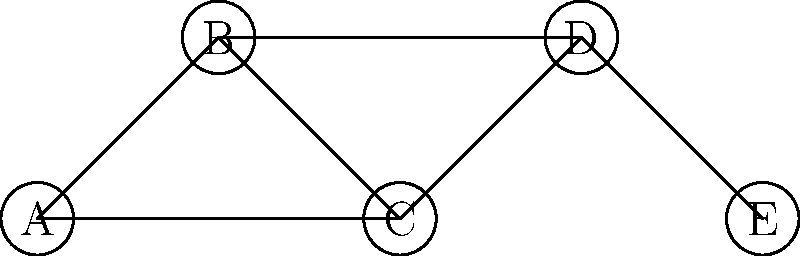In the diplomatic network shown, countries are represented by nodes and diplomatic relations by edges. If country C severs its diplomatic ties, what is the minimum number of new diplomatic relations that need to be established to ensure all remaining countries can still communicate through the network? To solve this problem, we need to follow these steps:

1. Identify the current connections:
   A-B, A-C, B-C, B-D, C-D, D-E

2. Remove country C and its connections:
   Remaining connections: A-B, B-D, D-E

3. Analyze the network without C:
   - Countries A and B are connected
   - Countries D and E are connected
   - There is no connection between (A,B) and (D,E)

4. Determine the minimum number of new connections needed:
   - To ensure all countries can communicate, we need to connect the two separated parts of the network
   - The most efficient way is to add one new connection between either A or B and either D or E

5. Verify the solution:
   - Adding one connection (e.g., B-E) would allow all countries to communicate:
     A-B-E-D

Therefore, the minimum number of new diplomatic relations needed is 1.
Answer: 1 